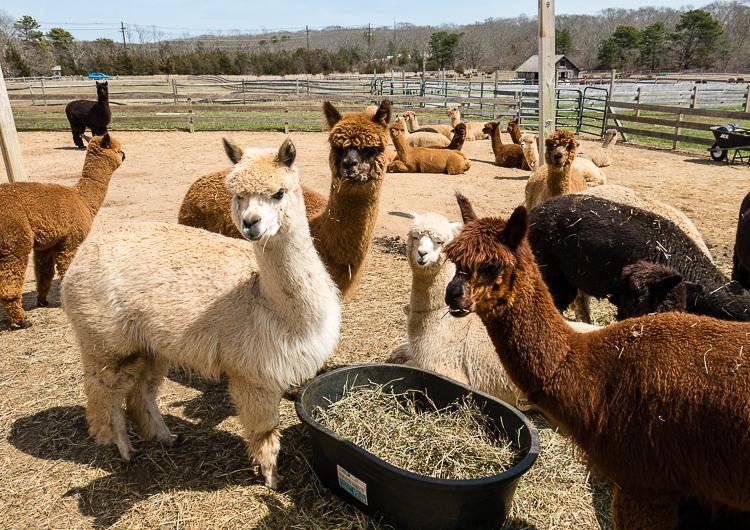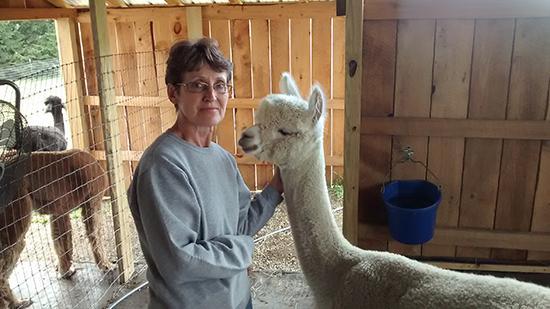The first image is the image on the left, the second image is the image on the right. Evaluate the accuracy of this statement regarding the images: "There are exactly six llamas in total.". Is it true? Answer yes or no. No. 